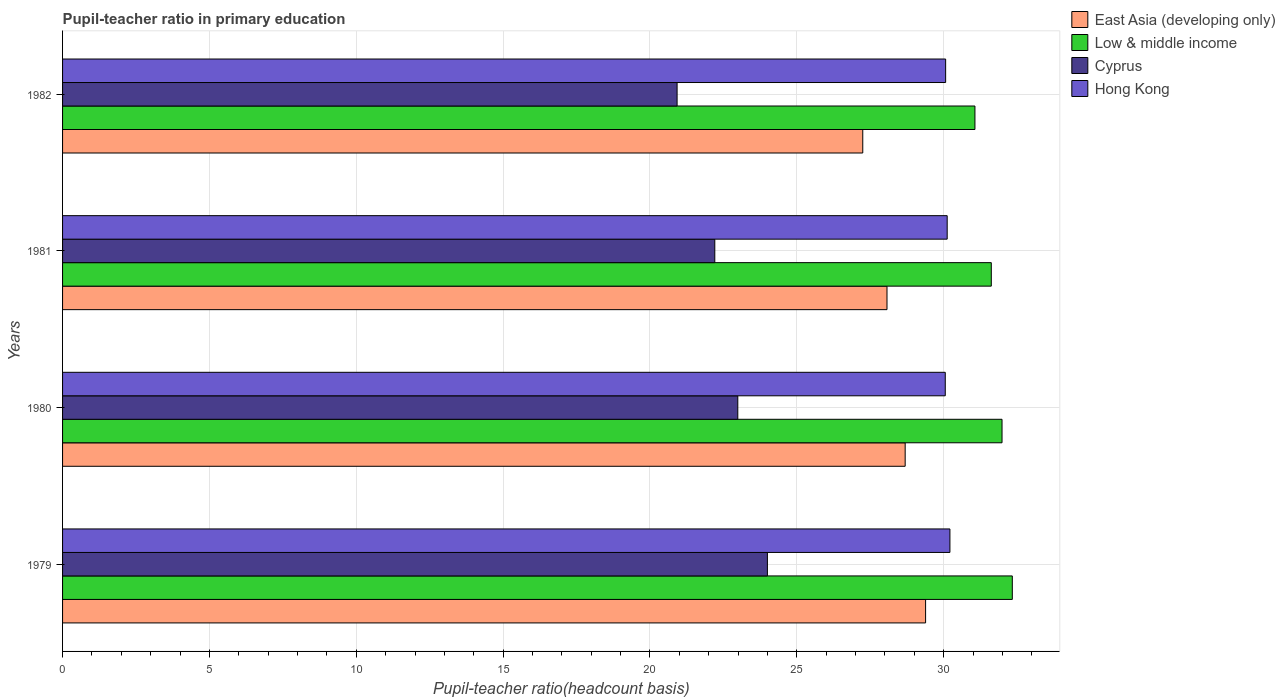Are the number of bars on each tick of the Y-axis equal?
Your response must be concise. Yes. How many bars are there on the 2nd tick from the top?
Keep it short and to the point. 4. What is the label of the 2nd group of bars from the top?
Keep it short and to the point. 1981. In how many cases, is the number of bars for a given year not equal to the number of legend labels?
Keep it short and to the point. 0. What is the pupil-teacher ratio in primary education in Cyprus in 1981?
Your response must be concise. 22.21. Across all years, what is the maximum pupil-teacher ratio in primary education in Low & middle income?
Provide a succinct answer. 32.34. Across all years, what is the minimum pupil-teacher ratio in primary education in Low & middle income?
Offer a terse response. 31.06. In which year was the pupil-teacher ratio in primary education in East Asia (developing only) maximum?
Provide a succinct answer. 1979. What is the total pupil-teacher ratio in primary education in East Asia (developing only) in the graph?
Offer a very short reply. 113.39. What is the difference between the pupil-teacher ratio in primary education in Cyprus in 1979 and that in 1980?
Offer a very short reply. 1.01. What is the difference between the pupil-teacher ratio in primary education in Low & middle income in 1981 and the pupil-teacher ratio in primary education in Cyprus in 1982?
Your answer should be compact. 10.7. What is the average pupil-teacher ratio in primary education in Hong Kong per year?
Your answer should be compact. 30.11. In the year 1980, what is the difference between the pupil-teacher ratio in primary education in Hong Kong and pupil-teacher ratio in primary education in Cyprus?
Offer a terse response. 7.06. What is the ratio of the pupil-teacher ratio in primary education in East Asia (developing only) in 1981 to that in 1982?
Offer a very short reply. 1.03. Is the difference between the pupil-teacher ratio in primary education in Hong Kong in 1979 and 1982 greater than the difference between the pupil-teacher ratio in primary education in Cyprus in 1979 and 1982?
Offer a terse response. No. What is the difference between the highest and the second highest pupil-teacher ratio in primary education in Hong Kong?
Your answer should be compact. 0.09. What is the difference between the highest and the lowest pupil-teacher ratio in primary education in Hong Kong?
Offer a very short reply. 0.16. In how many years, is the pupil-teacher ratio in primary education in Cyprus greater than the average pupil-teacher ratio in primary education in Cyprus taken over all years?
Make the answer very short. 2. Is the sum of the pupil-teacher ratio in primary education in Cyprus in 1981 and 1982 greater than the maximum pupil-teacher ratio in primary education in East Asia (developing only) across all years?
Provide a succinct answer. Yes. Is it the case that in every year, the sum of the pupil-teacher ratio in primary education in East Asia (developing only) and pupil-teacher ratio in primary education in Low & middle income is greater than the sum of pupil-teacher ratio in primary education in Hong Kong and pupil-teacher ratio in primary education in Cyprus?
Provide a short and direct response. Yes. Is it the case that in every year, the sum of the pupil-teacher ratio in primary education in East Asia (developing only) and pupil-teacher ratio in primary education in Cyprus is greater than the pupil-teacher ratio in primary education in Hong Kong?
Your answer should be compact. Yes. How many legend labels are there?
Your answer should be compact. 4. What is the title of the graph?
Your response must be concise. Pupil-teacher ratio in primary education. What is the label or title of the X-axis?
Ensure brevity in your answer.  Pupil-teacher ratio(headcount basis). What is the Pupil-teacher ratio(headcount basis) of East Asia (developing only) in 1979?
Keep it short and to the point. 29.38. What is the Pupil-teacher ratio(headcount basis) of Low & middle income in 1979?
Your response must be concise. 32.34. What is the Pupil-teacher ratio(headcount basis) of Cyprus in 1979?
Provide a short and direct response. 24. What is the Pupil-teacher ratio(headcount basis) of Hong Kong in 1979?
Offer a terse response. 30.21. What is the Pupil-teacher ratio(headcount basis) in East Asia (developing only) in 1980?
Provide a succinct answer. 28.69. What is the Pupil-teacher ratio(headcount basis) in Low & middle income in 1980?
Ensure brevity in your answer.  31.99. What is the Pupil-teacher ratio(headcount basis) of Cyprus in 1980?
Provide a succinct answer. 22.99. What is the Pupil-teacher ratio(headcount basis) in Hong Kong in 1980?
Keep it short and to the point. 30.05. What is the Pupil-teacher ratio(headcount basis) in East Asia (developing only) in 1981?
Keep it short and to the point. 28.07. What is the Pupil-teacher ratio(headcount basis) in Low & middle income in 1981?
Offer a terse response. 31.62. What is the Pupil-teacher ratio(headcount basis) in Cyprus in 1981?
Offer a very short reply. 22.21. What is the Pupil-teacher ratio(headcount basis) in Hong Kong in 1981?
Make the answer very short. 30.12. What is the Pupil-teacher ratio(headcount basis) in East Asia (developing only) in 1982?
Keep it short and to the point. 27.25. What is the Pupil-teacher ratio(headcount basis) of Low & middle income in 1982?
Your response must be concise. 31.06. What is the Pupil-teacher ratio(headcount basis) in Cyprus in 1982?
Provide a succinct answer. 20.92. What is the Pupil-teacher ratio(headcount basis) of Hong Kong in 1982?
Keep it short and to the point. 30.07. Across all years, what is the maximum Pupil-teacher ratio(headcount basis) in East Asia (developing only)?
Provide a short and direct response. 29.38. Across all years, what is the maximum Pupil-teacher ratio(headcount basis) in Low & middle income?
Your answer should be compact. 32.34. Across all years, what is the maximum Pupil-teacher ratio(headcount basis) of Cyprus?
Keep it short and to the point. 24. Across all years, what is the maximum Pupil-teacher ratio(headcount basis) in Hong Kong?
Provide a short and direct response. 30.21. Across all years, what is the minimum Pupil-teacher ratio(headcount basis) in East Asia (developing only)?
Ensure brevity in your answer.  27.25. Across all years, what is the minimum Pupil-teacher ratio(headcount basis) in Low & middle income?
Your answer should be compact. 31.06. Across all years, what is the minimum Pupil-teacher ratio(headcount basis) in Cyprus?
Provide a succinct answer. 20.92. Across all years, what is the minimum Pupil-teacher ratio(headcount basis) in Hong Kong?
Your response must be concise. 30.05. What is the total Pupil-teacher ratio(headcount basis) of East Asia (developing only) in the graph?
Your answer should be very brief. 113.39. What is the total Pupil-teacher ratio(headcount basis) of Low & middle income in the graph?
Give a very brief answer. 127.01. What is the total Pupil-teacher ratio(headcount basis) in Cyprus in the graph?
Your response must be concise. 90.12. What is the total Pupil-teacher ratio(headcount basis) in Hong Kong in the graph?
Offer a very short reply. 120.45. What is the difference between the Pupil-teacher ratio(headcount basis) of East Asia (developing only) in 1979 and that in 1980?
Provide a short and direct response. 0.7. What is the difference between the Pupil-teacher ratio(headcount basis) in Low & middle income in 1979 and that in 1980?
Your response must be concise. 0.35. What is the difference between the Pupil-teacher ratio(headcount basis) in Cyprus in 1979 and that in 1980?
Provide a short and direct response. 1.01. What is the difference between the Pupil-teacher ratio(headcount basis) in Hong Kong in 1979 and that in 1980?
Keep it short and to the point. 0.16. What is the difference between the Pupil-teacher ratio(headcount basis) in East Asia (developing only) in 1979 and that in 1981?
Your answer should be compact. 1.31. What is the difference between the Pupil-teacher ratio(headcount basis) in Low & middle income in 1979 and that in 1981?
Your response must be concise. 0.72. What is the difference between the Pupil-teacher ratio(headcount basis) in Cyprus in 1979 and that in 1981?
Provide a succinct answer. 1.79. What is the difference between the Pupil-teacher ratio(headcount basis) in Hong Kong in 1979 and that in 1981?
Offer a terse response. 0.09. What is the difference between the Pupil-teacher ratio(headcount basis) in East Asia (developing only) in 1979 and that in 1982?
Offer a terse response. 2.14. What is the difference between the Pupil-teacher ratio(headcount basis) of Low & middle income in 1979 and that in 1982?
Ensure brevity in your answer.  1.27. What is the difference between the Pupil-teacher ratio(headcount basis) of Cyprus in 1979 and that in 1982?
Your answer should be very brief. 3.07. What is the difference between the Pupil-teacher ratio(headcount basis) of Hong Kong in 1979 and that in 1982?
Your response must be concise. 0.15. What is the difference between the Pupil-teacher ratio(headcount basis) of East Asia (developing only) in 1980 and that in 1981?
Ensure brevity in your answer.  0.62. What is the difference between the Pupil-teacher ratio(headcount basis) of Low & middle income in 1980 and that in 1981?
Provide a short and direct response. 0.37. What is the difference between the Pupil-teacher ratio(headcount basis) in Cyprus in 1980 and that in 1981?
Make the answer very short. 0.78. What is the difference between the Pupil-teacher ratio(headcount basis) of Hong Kong in 1980 and that in 1981?
Your response must be concise. -0.07. What is the difference between the Pupil-teacher ratio(headcount basis) in East Asia (developing only) in 1980 and that in 1982?
Provide a short and direct response. 1.44. What is the difference between the Pupil-teacher ratio(headcount basis) in Low & middle income in 1980 and that in 1982?
Keep it short and to the point. 0.92. What is the difference between the Pupil-teacher ratio(headcount basis) in Cyprus in 1980 and that in 1982?
Provide a short and direct response. 2.07. What is the difference between the Pupil-teacher ratio(headcount basis) in Hong Kong in 1980 and that in 1982?
Ensure brevity in your answer.  -0.01. What is the difference between the Pupil-teacher ratio(headcount basis) of East Asia (developing only) in 1981 and that in 1982?
Your answer should be very brief. 0.83. What is the difference between the Pupil-teacher ratio(headcount basis) in Low & middle income in 1981 and that in 1982?
Your answer should be compact. 0.56. What is the difference between the Pupil-teacher ratio(headcount basis) in Cyprus in 1981 and that in 1982?
Make the answer very short. 1.28. What is the difference between the Pupil-teacher ratio(headcount basis) in Hong Kong in 1981 and that in 1982?
Your answer should be compact. 0.05. What is the difference between the Pupil-teacher ratio(headcount basis) of East Asia (developing only) in 1979 and the Pupil-teacher ratio(headcount basis) of Low & middle income in 1980?
Your answer should be compact. -2.6. What is the difference between the Pupil-teacher ratio(headcount basis) in East Asia (developing only) in 1979 and the Pupil-teacher ratio(headcount basis) in Cyprus in 1980?
Offer a very short reply. 6.39. What is the difference between the Pupil-teacher ratio(headcount basis) in East Asia (developing only) in 1979 and the Pupil-teacher ratio(headcount basis) in Hong Kong in 1980?
Provide a succinct answer. -0.67. What is the difference between the Pupil-teacher ratio(headcount basis) of Low & middle income in 1979 and the Pupil-teacher ratio(headcount basis) of Cyprus in 1980?
Offer a terse response. 9.35. What is the difference between the Pupil-teacher ratio(headcount basis) in Low & middle income in 1979 and the Pupil-teacher ratio(headcount basis) in Hong Kong in 1980?
Your answer should be compact. 2.28. What is the difference between the Pupil-teacher ratio(headcount basis) in Cyprus in 1979 and the Pupil-teacher ratio(headcount basis) in Hong Kong in 1980?
Your response must be concise. -6.06. What is the difference between the Pupil-teacher ratio(headcount basis) of East Asia (developing only) in 1979 and the Pupil-teacher ratio(headcount basis) of Low & middle income in 1981?
Your response must be concise. -2.24. What is the difference between the Pupil-teacher ratio(headcount basis) of East Asia (developing only) in 1979 and the Pupil-teacher ratio(headcount basis) of Cyprus in 1981?
Ensure brevity in your answer.  7.18. What is the difference between the Pupil-teacher ratio(headcount basis) of East Asia (developing only) in 1979 and the Pupil-teacher ratio(headcount basis) of Hong Kong in 1981?
Give a very brief answer. -0.74. What is the difference between the Pupil-teacher ratio(headcount basis) of Low & middle income in 1979 and the Pupil-teacher ratio(headcount basis) of Cyprus in 1981?
Your answer should be very brief. 10.13. What is the difference between the Pupil-teacher ratio(headcount basis) of Low & middle income in 1979 and the Pupil-teacher ratio(headcount basis) of Hong Kong in 1981?
Offer a very short reply. 2.22. What is the difference between the Pupil-teacher ratio(headcount basis) of Cyprus in 1979 and the Pupil-teacher ratio(headcount basis) of Hong Kong in 1981?
Ensure brevity in your answer.  -6.12. What is the difference between the Pupil-teacher ratio(headcount basis) of East Asia (developing only) in 1979 and the Pupil-teacher ratio(headcount basis) of Low & middle income in 1982?
Your answer should be compact. -1.68. What is the difference between the Pupil-teacher ratio(headcount basis) of East Asia (developing only) in 1979 and the Pupil-teacher ratio(headcount basis) of Cyprus in 1982?
Your response must be concise. 8.46. What is the difference between the Pupil-teacher ratio(headcount basis) of East Asia (developing only) in 1979 and the Pupil-teacher ratio(headcount basis) of Hong Kong in 1982?
Ensure brevity in your answer.  -0.68. What is the difference between the Pupil-teacher ratio(headcount basis) in Low & middle income in 1979 and the Pupil-teacher ratio(headcount basis) in Cyprus in 1982?
Offer a terse response. 11.41. What is the difference between the Pupil-teacher ratio(headcount basis) of Low & middle income in 1979 and the Pupil-teacher ratio(headcount basis) of Hong Kong in 1982?
Offer a very short reply. 2.27. What is the difference between the Pupil-teacher ratio(headcount basis) in Cyprus in 1979 and the Pupil-teacher ratio(headcount basis) in Hong Kong in 1982?
Your answer should be compact. -6.07. What is the difference between the Pupil-teacher ratio(headcount basis) in East Asia (developing only) in 1980 and the Pupil-teacher ratio(headcount basis) in Low & middle income in 1981?
Offer a very short reply. -2.93. What is the difference between the Pupil-teacher ratio(headcount basis) of East Asia (developing only) in 1980 and the Pupil-teacher ratio(headcount basis) of Cyprus in 1981?
Your answer should be very brief. 6.48. What is the difference between the Pupil-teacher ratio(headcount basis) of East Asia (developing only) in 1980 and the Pupil-teacher ratio(headcount basis) of Hong Kong in 1981?
Give a very brief answer. -1.43. What is the difference between the Pupil-teacher ratio(headcount basis) of Low & middle income in 1980 and the Pupil-teacher ratio(headcount basis) of Cyprus in 1981?
Ensure brevity in your answer.  9.78. What is the difference between the Pupil-teacher ratio(headcount basis) of Low & middle income in 1980 and the Pupil-teacher ratio(headcount basis) of Hong Kong in 1981?
Your response must be concise. 1.87. What is the difference between the Pupil-teacher ratio(headcount basis) of Cyprus in 1980 and the Pupil-teacher ratio(headcount basis) of Hong Kong in 1981?
Keep it short and to the point. -7.13. What is the difference between the Pupil-teacher ratio(headcount basis) of East Asia (developing only) in 1980 and the Pupil-teacher ratio(headcount basis) of Low & middle income in 1982?
Provide a succinct answer. -2.38. What is the difference between the Pupil-teacher ratio(headcount basis) in East Asia (developing only) in 1980 and the Pupil-teacher ratio(headcount basis) in Cyprus in 1982?
Your response must be concise. 7.77. What is the difference between the Pupil-teacher ratio(headcount basis) of East Asia (developing only) in 1980 and the Pupil-teacher ratio(headcount basis) of Hong Kong in 1982?
Your answer should be compact. -1.38. What is the difference between the Pupil-teacher ratio(headcount basis) of Low & middle income in 1980 and the Pupil-teacher ratio(headcount basis) of Cyprus in 1982?
Provide a short and direct response. 11.06. What is the difference between the Pupil-teacher ratio(headcount basis) of Low & middle income in 1980 and the Pupil-teacher ratio(headcount basis) of Hong Kong in 1982?
Offer a terse response. 1.92. What is the difference between the Pupil-teacher ratio(headcount basis) in Cyprus in 1980 and the Pupil-teacher ratio(headcount basis) in Hong Kong in 1982?
Make the answer very short. -7.08. What is the difference between the Pupil-teacher ratio(headcount basis) in East Asia (developing only) in 1981 and the Pupil-teacher ratio(headcount basis) in Low & middle income in 1982?
Ensure brevity in your answer.  -2.99. What is the difference between the Pupil-teacher ratio(headcount basis) in East Asia (developing only) in 1981 and the Pupil-teacher ratio(headcount basis) in Cyprus in 1982?
Your answer should be compact. 7.15. What is the difference between the Pupil-teacher ratio(headcount basis) in East Asia (developing only) in 1981 and the Pupil-teacher ratio(headcount basis) in Hong Kong in 1982?
Your answer should be compact. -2. What is the difference between the Pupil-teacher ratio(headcount basis) in Low & middle income in 1981 and the Pupil-teacher ratio(headcount basis) in Cyprus in 1982?
Provide a succinct answer. 10.7. What is the difference between the Pupil-teacher ratio(headcount basis) of Low & middle income in 1981 and the Pupil-teacher ratio(headcount basis) of Hong Kong in 1982?
Provide a succinct answer. 1.55. What is the difference between the Pupil-teacher ratio(headcount basis) in Cyprus in 1981 and the Pupil-teacher ratio(headcount basis) in Hong Kong in 1982?
Your answer should be very brief. -7.86. What is the average Pupil-teacher ratio(headcount basis) in East Asia (developing only) per year?
Your answer should be very brief. 28.35. What is the average Pupil-teacher ratio(headcount basis) in Low & middle income per year?
Ensure brevity in your answer.  31.75. What is the average Pupil-teacher ratio(headcount basis) in Cyprus per year?
Your response must be concise. 22.53. What is the average Pupil-teacher ratio(headcount basis) of Hong Kong per year?
Make the answer very short. 30.11. In the year 1979, what is the difference between the Pupil-teacher ratio(headcount basis) in East Asia (developing only) and Pupil-teacher ratio(headcount basis) in Low & middle income?
Make the answer very short. -2.95. In the year 1979, what is the difference between the Pupil-teacher ratio(headcount basis) in East Asia (developing only) and Pupil-teacher ratio(headcount basis) in Cyprus?
Give a very brief answer. 5.39. In the year 1979, what is the difference between the Pupil-teacher ratio(headcount basis) in East Asia (developing only) and Pupil-teacher ratio(headcount basis) in Hong Kong?
Give a very brief answer. -0.83. In the year 1979, what is the difference between the Pupil-teacher ratio(headcount basis) in Low & middle income and Pupil-teacher ratio(headcount basis) in Cyprus?
Ensure brevity in your answer.  8.34. In the year 1979, what is the difference between the Pupil-teacher ratio(headcount basis) of Low & middle income and Pupil-teacher ratio(headcount basis) of Hong Kong?
Offer a terse response. 2.12. In the year 1979, what is the difference between the Pupil-teacher ratio(headcount basis) in Cyprus and Pupil-teacher ratio(headcount basis) in Hong Kong?
Provide a short and direct response. -6.21. In the year 1980, what is the difference between the Pupil-teacher ratio(headcount basis) in East Asia (developing only) and Pupil-teacher ratio(headcount basis) in Low & middle income?
Offer a terse response. -3.3. In the year 1980, what is the difference between the Pupil-teacher ratio(headcount basis) of East Asia (developing only) and Pupil-teacher ratio(headcount basis) of Cyprus?
Provide a succinct answer. 5.7. In the year 1980, what is the difference between the Pupil-teacher ratio(headcount basis) in East Asia (developing only) and Pupil-teacher ratio(headcount basis) in Hong Kong?
Provide a succinct answer. -1.37. In the year 1980, what is the difference between the Pupil-teacher ratio(headcount basis) of Low & middle income and Pupil-teacher ratio(headcount basis) of Cyprus?
Keep it short and to the point. 9. In the year 1980, what is the difference between the Pupil-teacher ratio(headcount basis) in Low & middle income and Pupil-teacher ratio(headcount basis) in Hong Kong?
Your response must be concise. 1.93. In the year 1980, what is the difference between the Pupil-teacher ratio(headcount basis) of Cyprus and Pupil-teacher ratio(headcount basis) of Hong Kong?
Your response must be concise. -7.06. In the year 1981, what is the difference between the Pupil-teacher ratio(headcount basis) in East Asia (developing only) and Pupil-teacher ratio(headcount basis) in Low & middle income?
Provide a short and direct response. -3.55. In the year 1981, what is the difference between the Pupil-teacher ratio(headcount basis) in East Asia (developing only) and Pupil-teacher ratio(headcount basis) in Cyprus?
Offer a terse response. 5.86. In the year 1981, what is the difference between the Pupil-teacher ratio(headcount basis) of East Asia (developing only) and Pupil-teacher ratio(headcount basis) of Hong Kong?
Offer a very short reply. -2.05. In the year 1981, what is the difference between the Pupil-teacher ratio(headcount basis) of Low & middle income and Pupil-teacher ratio(headcount basis) of Cyprus?
Make the answer very short. 9.41. In the year 1981, what is the difference between the Pupil-teacher ratio(headcount basis) of Low & middle income and Pupil-teacher ratio(headcount basis) of Hong Kong?
Your answer should be compact. 1.5. In the year 1981, what is the difference between the Pupil-teacher ratio(headcount basis) in Cyprus and Pupil-teacher ratio(headcount basis) in Hong Kong?
Make the answer very short. -7.91. In the year 1982, what is the difference between the Pupil-teacher ratio(headcount basis) in East Asia (developing only) and Pupil-teacher ratio(headcount basis) in Low & middle income?
Offer a very short reply. -3.82. In the year 1982, what is the difference between the Pupil-teacher ratio(headcount basis) in East Asia (developing only) and Pupil-teacher ratio(headcount basis) in Cyprus?
Provide a succinct answer. 6.32. In the year 1982, what is the difference between the Pupil-teacher ratio(headcount basis) of East Asia (developing only) and Pupil-teacher ratio(headcount basis) of Hong Kong?
Give a very brief answer. -2.82. In the year 1982, what is the difference between the Pupil-teacher ratio(headcount basis) of Low & middle income and Pupil-teacher ratio(headcount basis) of Cyprus?
Your response must be concise. 10.14. In the year 1982, what is the difference between the Pupil-teacher ratio(headcount basis) in Cyprus and Pupil-teacher ratio(headcount basis) in Hong Kong?
Make the answer very short. -9.14. What is the ratio of the Pupil-teacher ratio(headcount basis) in East Asia (developing only) in 1979 to that in 1980?
Your answer should be compact. 1.02. What is the ratio of the Pupil-teacher ratio(headcount basis) in Cyprus in 1979 to that in 1980?
Your response must be concise. 1.04. What is the ratio of the Pupil-teacher ratio(headcount basis) in Hong Kong in 1979 to that in 1980?
Provide a succinct answer. 1.01. What is the ratio of the Pupil-teacher ratio(headcount basis) in East Asia (developing only) in 1979 to that in 1981?
Your response must be concise. 1.05. What is the ratio of the Pupil-teacher ratio(headcount basis) of Low & middle income in 1979 to that in 1981?
Your response must be concise. 1.02. What is the ratio of the Pupil-teacher ratio(headcount basis) of Cyprus in 1979 to that in 1981?
Offer a terse response. 1.08. What is the ratio of the Pupil-teacher ratio(headcount basis) in Hong Kong in 1979 to that in 1981?
Provide a short and direct response. 1. What is the ratio of the Pupil-teacher ratio(headcount basis) in East Asia (developing only) in 1979 to that in 1982?
Your answer should be very brief. 1.08. What is the ratio of the Pupil-teacher ratio(headcount basis) in Low & middle income in 1979 to that in 1982?
Your response must be concise. 1.04. What is the ratio of the Pupil-teacher ratio(headcount basis) of Cyprus in 1979 to that in 1982?
Your answer should be compact. 1.15. What is the ratio of the Pupil-teacher ratio(headcount basis) of Hong Kong in 1979 to that in 1982?
Provide a succinct answer. 1. What is the ratio of the Pupil-teacher ratio(headcount basis) in Low & middle income in 1980 to that in 1981?
Provide a succinct answer. 1.01. What is the ratio of the Pupil-teacher ratio(headcount basis) in Cyprus in 1980 to that in 1981?
Keep it short and to the point. 1.04. What is the ratio of the Pupil-teacher ratio(headcount basis) of Hong Kong in 1980 to that in 1981?
Give a very brief answer. 1. What is the ratio of the Pupil-teacher ratio(headcount basis) of East Asia (developing only) in 1980 to that in 1982?
Ensure brevity in your answer.  1.05. What is the ratio of the Pupil-teacher ratio(headcount basis) in Low & middle income in 1980 to that in 1982?
Your answer should be very brief. 1.03. What is the ratio of the Pupil-teacher ratio(headcount basis) of Cyprus in 1980 to that in 1982?
Give a very brief answer. 1.1. What is the ratio of the Pupil-teacher ratio(headcount basis) in Hong Kong in 1980 to that in 1982?
Your answer should be compact. 1. What is the ratio of the Pupil-teacher ratio(headcount basis) of East Asia (developing only) in 1981 to that in 1982?
Your answer should be very brief. 1.03. What is the ratio of the Pupil-teacher ratio(headcount basis) of Low & middle income in 1981 to that in 1982?
Your response must be concise. 1.02. What is the ratio of the Pupil-teacher ratio(headcount basis) of Cyprus in 1981 to that in 1982?
Provide a short and direct response. 1.06. What is the ratio of the Pupil-teacher ratio(headcount basis) in Hong Kong in 1981 to that in 1982?
Your answer should be compact. 1. What is the difference between the highest and the second highest Pupil-teacher ratio(headcount basis) in East Asia (developing only)?
Your answer should be very brief. 0.7. What is the difference between the highest and the second highest Pupil-teacher ratio(headcount basis) in Low & middle income?
Make the answer very short. 0.35. What is the difference between the highest and the second highest Pupil-teacher ratio(headcount basis) in Cyprus?
Offer a terse response. 1.01. What is the difference between the highest and the second highest Pupil-teacher ratio(headcount basis) in Hong Kong?
Your answer should be compact. 0.09. What is the difference between the highest and the lowest Pupil-teacher ratio(headcount basis) in East Asia (developing only)?
Your response must be concise. 2.14. What is the difference between the highest and the lowest Pupil-teacher ratio(headcount basis) in Low & middle income?
Provide a succinct answer. 1.27. What is the difference between the highest and the lowest Pupil-teacher ratio(headcount basis) in Cyprus?
Offer a terse response. 3.07. What is the difference between the highest and the lowest Pupil-teacher ratio(headcount basis) in Hong Kong?
Offer a terse response. 0.16. 